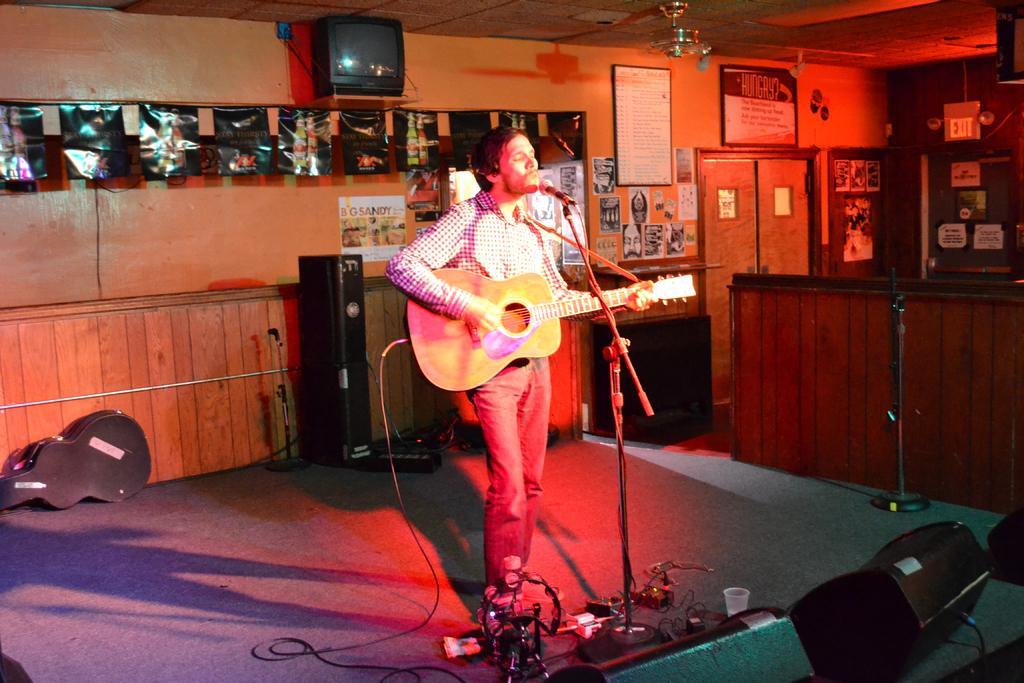How would you summarize this image in a sentence or two? In this picture a guy is playing a guitar with a mic placed in front of him. In the background we observe few musical instruments and posters attached to the wall. There is also a television placed on the top of the wall. 